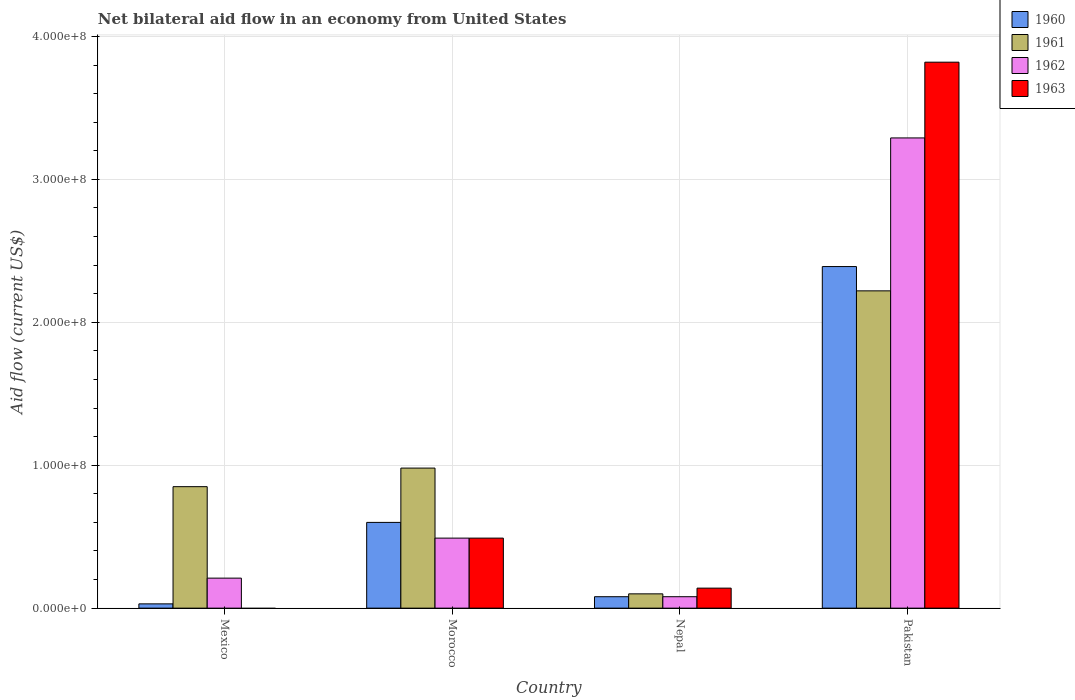How many different coloured bars are there?
Provide a succinct answer. 4. How many groups of bars are there?
Make the answer very short. 4. Are the number of bars on each tick of the X-axis equal?
Your answer should be compact. No. How many bars are there on the 3rd tick from the right?
Make the answer very short. 4. What is the label of the 3rd group of bars from the left?
Ensure brevity in your answer.  Nepal. What is the net bilateral aid flow in 1961 in Morocco?
Your answer should be very brief. 9.80e+07. Across all countries, what is the maximum net bilateral aid flow in 1960?
Keep it short and to the point. 2.39e+08. Across all countries, what is the minimum net bilateral aid flow in 1963?
Offer a terse response. 0. In which country was the net bilateral aid flow in 1961 maximum?
Offer a terse response. Pakistan. What is the total net bilateral aid flow in 1961 in the graph?
Ensure brevity in your answer.  4.15e+08. What is the difference between the net bilateral aid flow in 1962 in Nepal and that in Pakistan?
Make the answer very short. -3.21e+08. What is the difference between the net bilateral aid flow in 1962 in Mexico and the net bilateral aid flow in 1963 in Pakistan?
Your answer should be very brief. -3.61e+08. What is the average net bilateral aid flow in 1963 per country?
Your response must be concise. 1.11e+08. What is the difference between the net bilateral aid flow of/in 1963 and net bilateral aid flow of/in 1961 in Pakistan?
Keep it short and to the point. 1.60e+08. In how many countries, is the net bilateral aid flow in 1962 greater than 300000000 US$?
Offer a terse response. 1. What is the ratio of the net bilateral aid flow in 1963 in Morocco to that in Pakistan?
Offer a very short reply. 0.13. What is the difference between the highest and the second highest net bilateral aid flow in 1960?
Make the answer very short. 1.79e+08. What is the difference between the highest and the lowest net bilateral aid flow in 1961?
Your response must be concise. 2.12e+08. Is it the case that in every country, the sum of the net bilateral aid flow in 1961 and net bilateral aid flow in 1960 is greater than the sum of net bilateral aid flow in 1963 and net bilateral aid flow in 1962?
Keep it short and to the point. No. Is it the case that in every country, the sum of the net bilateral aid flow in 1961 and net bilateral aid flow in 1963 is greater than the net bilateral aid flow in 1960?
Ensure brevity in your answer.  Yes. How many bars are there?
Provide a short and direct response. 15. Are all the bars in the graph horizontal?
Your answer should be compact. No. How many countries are there in the graph?
Give a very brief answer. 4. Are the values on the major ticks of Y-axis written in scientific E-notation?
Your answer should be very brief. Yes. Does the graph contain any zero values?
Ensure brevity in your answer.  Yes. Where does the legend appear in the graph?
Offer a terse response. Top right. How many legend labels are there?
Your answer should be compact. 4. What is the title of the graph?
Your answer should be compact. Net bilateral aid flow in an economy from United States. What is the label or title of the X-axis?
Keep it short and to the point. Country. What is the label or title of the Y-axis?
Give a very brief answer. Aid flow (current US$). What is the Aid flow (current US$) of 1960 in Mexico?
Provide a short and direct response. 3.00e+06. What is the Aid flow (current US$) in 1961 in Mexico?
Make the answer very short. 8.50e+07. What is the Aid flow (current US$) of 1962 in Mexico?
Give a very brief answer. 2.10e+07. What is the Aid flow (current US$) in 1960 in Morocco?
Offer a terse response. 6.00e+07. What is the Aid flow (current US$) of 1961 in Morocco?
Make the answer very short. 9.80e+07. What is the Aid flow (current US$) in 1962 in Morocco?
Your answer should be compact. 4.90e+07. What is the Aid flow (current US$) in 1963 in Morocco?
Your answer should be compact. 4.90e+07. What is the Aid flow (current US$) in 1962 in Nepal?
Your response must be concise. 8.00e+06. What is the Aid flow (current US$) in 1963 in Nepal?
Ensure brevity in your answer.  1.40e+07. What is the Aid flow (current US$) in 1960 in Pakistan?
Offer a terse response. 2.39e+08. What is the Aid flow (current US$) in 1961 in Pakistan?
Offer a very short reply. 2.22e+08. What is the Aid flow (current US$) of 1962 in Pakistan?
Ensure brevity in your answer.  3.29e+08. What is the Aid flow (current US$) of 1963 in Pakistan?
Ensure brevity in your answer.  3.82e+08. Across all countries, what is the maximum Aid flow (current US$) in 1960?
Keep it short and to the point. 2.39e+08. Across all countries, what is the maximum Aid flow (current US$) in 1961?
Keep it short and to the point. 2.22e+08. Across all countries, what is the maximum Aid flow (current US$) of 1962?
Give a very brief answer. 3.29e+08. Across all countries, what is the maximum Aid flow (current US$) of 1963?
Give a very brief answer. 3.82e+08. Across all countries, what is the minimum Aid flow (current US$) of 1960?
Your answer should be compact. 3.00e+06. Across all countries, what is the minimum Aid flow (current US$) in 1963?
Your response must be concise. 0. What is the total Aid flow (current US$) of 1960 in the graph?
Keep it short and to the point. 3.10e+08. What is the total Aid flow (current US$) in 1961 in the graph?
Your answer should be compact. 4.15e+08. What is the total Aid flow (current US$) in 1962 in the graph?
Offer a terse response. 4.07e+08. What is the total Aid flow (current US$) of 1963 in the graph?
Your answer should be compact. 4.45e+08. What is the difference between the Aid flow (current US$) of 1960 in Mexico and that in Morocco?
Keep it short and to the point. -5.70e+07. What is the difference between the Aid flow (current US$) in 1961 in Mexico and that in Morocco?
Make the answer very short. -1.30e+07. What is the difference between the Aid flow (current US$) of 1962 in Mexico and that in Morocco?
Offer a very short reply. -2.80e+07. What is the difference between the Aid flow (current US$) in 1960 in Mexico and that in Nepal?
Offer a very short reply. -5.00e+06. What is the difference between the Aid flow (current US$) in 1961 in Mexico and that in Nepal?
Provide a short and direct response. 7.50e+07. What is the difference between the Aid flow (current US$) of 1962 in Mexico and that in Nepal?
Ensure brevity in your answer.  1.30e+07. What is the difference between the Aid flow (current US$) of 1960 in Mexico and that in Pakistan?
Your response must be concise. -2.36e+08. What is the difference between the Aid flow (current US$) in 1961 in Mexico and that in Pakistan?
Provide a short and direct response. -1.37e+08. What is the difference between the Aid flow (current US$) in 1962 in Mexico and that in Pakistan?
Keep it short and to the point. -3.08e+08. What is the difference between the Aid flow (current US$) of 1960 in Morocco and that in Nepal?
Offer a very short reply. 5.20e+07. What is the difference between the Aid flow (current US$) in 1961 in Morocco and that in Nepal?
Ensure brevity in your answer.  8.80e+07. What is the difference between the Aid flow (current US$) of 1962 in Morocco and that in Nepal?
Ensure brevity in your answer.  4.10e+07. What is the difference between the Aid flow (current US$) in 1963 in Morocco and that in Nepal?
Ensure brevity in your answer.  3.50e+07. What is the difference between the Aid flow (current US$) in 1960 in Morocco and that in Pakistan?
Your answer should be very brief. -1.79e+08. What is the difference between the Aid flow (current US$) of 1961 in Morocco and that in Pakistan?
Provide a succinct answer. -1.24e+08. What is the difference between the Aid flow (current US$) in 1962 in Morocco and that in Pakistan?
Make the answer very short. -2.80e+08. What is the difference between the Aid flow (current US$) of 1963 in Morocco and that in Pakistan?
Your response must be concise. -3.33e+08. What is the difference between the Aid flow (current US$) of 1960 in Nepal and that in Pakistan?
Give a very brief answer. -2.31e+08. What is the difference between the Aid flow (current US$) in 1961 in Nepal and that in Pakistan?
Keep it short and to the point. -2.12e+08. What is the difference between the Aid flow (current US$) in 1962 in Nepal and that in Pakistan?
Give a very brief answer. -3.21e+08. What is the difference between the Aid flow (current US$) of 1963 in Nepal and that in Pakistan?
Provide a succinct answer. -3.68e+08. What is the difference between the Aid flow (current US$) in 1960 in Mexico and the Aid flow (current US$) in 1961 in Morocco?
Offer a very short reply. -9.50e+07. What is the difference between the Aid flow (current US$) of 1960 in Mexico and the Aid flow (current US$) of 1962 in Morocco?
Offer a very short reply. -4.60e+07. What is the difference between the Aid flow (current US$) of 1960 in Mexico and the Aid flow (current US$) of 1963 in Morocco?
Your response must be concise. -4.60e+07. What is the difference between the Aid flow (current US$) of 1961 in Mexico and the Aid flow (current US$) of 1962 in Morocco?
Give a very brief answer. 3.60e+07. What is the difference between the Aid flow (current US$) in 1961 in Mexico and the Aid flow (current US$) in 1963 in Morocco?
Keep it short and to the point. 3.60e+07. What is the difference between the Aid flow (current US$) of 1962 in Mexico and the Aid flow (current US$) of 1963 in Morocco?
Offer a terse response. -2.80e+07. What is the difference between the Aid flow (current US$) of 1960 in Mexico and the Aid flow (current US$) of 1961 in Nepal?
Your answer should be very brief. -7.00e+06. What is the difference between the Aid flow (current US$) in 1960 in Mexico and the Aid flow (current US$) in 1962 in Nepal?
Keep it short and to the point. -5.00e+06. What is the difference between the Aid flow (current US$) in 1960 in Mexico and the Aid flow (current US$) in 1963 in Nepal?
Your answer should be very brief. -1.10e+07. What is the difference between the Aid flow (current US$) in 1961 in Mexico and the Aid flow (current US$) in 1962 in Nepal?
Keep it short and to the point. 7.70e+07. What is the difference between the Aid flow (current US$) in 1961 in Mexico and the Aid flow (current US$) in 1963 in Nepal?
Offer a terse response. 7.10e+07. What is the difference between the Aid flow (current US$) in 1960 in Mexico and the Aid flow (current US$) in 1961 in Pakistan?
Provide a succinct answer. -2.19e+08. What is the difference between the Aid flow (current US$) in 1960 in Mexico and the Aid flow (current US$) in 1962 in Pakistan?
Your response must be concise. -3.26e+08. What is the difference between the Aid flow (current US$) in 1960 in Mexico and the Aid flow (current US$) in 1963 in Pakistan?
Your answer should be very brief. -3.79e+08. What is the difference between the Aid flow (current US$) in 1961 in Mexico and the Aid flow (current US$) in 1962 in Pakistan?
Provide a short and direct response. -2.44e+08. What is the difference between the Aid flow (current US$) of 1961 in Mexico and the Aid flow (current US$) of 1963 in Pakistan?
Ensure brevity in your answer.  -2.97e+08. What is the difference between the Aid flow (current US$) of 1962 in Mexico and the Aid flow (current US$) of 1963 in Pakistan?
Provide a succinct answer. -3.61e+08. What is the difference between the Aid flow (current US$) of 1960 in Morocco and the Aid flow (current US$) of 1961 in Nepal?
Offer a terse response. 5.00e+07. What is the difference between the Aid flow (current US$) in 1960 in Morocco and the Aid flow (current US$) in 1962 in Nepal?
Your answer should be very brief. 5.20e+07. What is the difference between the Aid flow (current US$) in 1960 in Morocco and the Aid flow (current US$) in 1963 in Nepal?
Make the answer very short. 4.60e+07. What is the difference between the Aid flow (current US$) of 1961 in Morocco and the Aid flow (current US$) of 1962 in Nepal?
Your response must be concise. 9.00e+07. What is the difference between the Aid flow (current US$) of 1961 in Morocco and the Aid flow (current US$) of 1963 in Nepal?
Provide a short and direct response. 8.40e+07. What is the difference between the Aid flow (current US$) of 1962 in Morocco and the Aid flow (current US$) of 1963 in Nepal?
Your answer should be compact. 3.50e+07. What is the difference between the Aid flow (current US$) of 1960 in Morocco and the Aid flow (current US$) of 1961 in Pakistan?
Offer a terse response. -1.62e+08. What is the difference between the Aid flow (current US$) of 1960 in Morocco and the Aid flow (current US$) of 1962 in Pakistan?
Your response must be concise. -2.69e+08. What is the difference between the Aid flow (current US$) in 1960 in Morocco and the Aid flow (current US$) in 1963 in Pakistan?
Your answer should be compact. -3.22e+08. What is the difference between the Aid flow (current US$) of 1961 in Morocco and the Aid flow (current US$) of 1962 in Pakistan?
Offer a very short reply. -2.31e+08. What is the difference between the Aid flow (current US$) in 1961 in Morocco and the Aid flow (current US$) in 1963 in Pakistan?
Give a very brief answer. -2.84e+08. What is the difference between the Aid flow (current US$) of 1962 in Morocco and the Aid flow (current US$) of 1963 in Pakistan?
Your answer should be very brief. -3.33e+08. What is the difference between the Aid flow (current US$) of 1960 in Nepal and the Aid flow (current US$) of 1961 in Pakistan?
Keep it short and to the point. -2.14e+08. What is the difference between the Aid flow (current US$) of 1960 in Nepal and the Aid flow (current US$) of 1962 in Pakistan?
Ensure brevity in your answer.  -3.21e+08. What is the difference between the Aid flow (current US$) of 1960 in Nepal and the Aid flow (current US$) of 1963 in Pakistan?
Ensure brevity in your answer.  -3.74e+08. What is the difference between the Aid flow (current US$) in 1961 in Nepal and the Aid flow (current US$) in 1962 in Pakistan?
Ensure brevity in your answer.  -3.19e+08. What is the difference between the Aid flow (current US$) of 1961 in Nepal and the Aid flow (current US$) of 1963 in Pakistan?
Ensure brevity in your answer.  -3.72e+08. What is the difference between the Aid flow (current US$) of 1962 in Nepal and the Aid flow (current US$) of 1963 in Pakistan?
Your answer should be very brief. -3.74e+08. What is the average Aid flow (current US$) of 1960 per country?
Give a very brief answer. 7.75e+07. What is the average Aid flow (current US$) in 1961 per country?
Your answer should be compact. 1.04e+08. What is the average Aid flow (current US$) in 1962 per country?
Offer a very short reply. 1.02e+08. What is the average Aid flow (current US$) in 1963 per country?
Make the answer very short. 1.11e+08. What is the difference between the Aid flow (current US$) of 1960 and Aid flow (current US$) of 1961 in Mexico?
Offer a terse response. -8.20e+07. What is the difference between the Aid flow (current US$) in 1960 and Aid flow (current US$) in 1962 in Mexico?
Provide a succinct answer. -1.80e+07. What is the difference between the Aid flow (current US$) of 1961 and Aid flow (current US$) of 1962 in Mexico?
Your answer should be compact. 6.40e+07. What is the difference between the Aid flow (current US$) of 1960 and Aid flow (current US$) of 1961 in Morocco?
Ensure brevity in your answer.  -3.80e+07. What is the difference between the Aid flow (current US$) in 1960 and Aid flow (current US$) in 1962 in Morocco?
Your answer should be compact. 1.10e+07. What is the difference between the Aid flow (current US$) of 1960 and Aid flow (current US$) of 1963 in Morocco?
Give a very brief answer. 1.10e+07. What is the difference between the Aid flow (current US$) of 1961 and Aid flow (current US$) of 1962 in Morocco?
Make the answer very short. 4.90e+07. What is the difference between the Aid flow (current US$) in 1961 and Aid flow (current US$) in 1963 in Morocco?
Keep it short and to the point. 4.90e+07. What is the difference between the Aid flow (current US$) in 1960 and Aid flow (current US$) in 1962 in Nepal?
Your answer should be compact. 0. What is the difference between the Aid flow (current US$) of 1960 and Aid flow (current US$) of 1963 in Nepal?
Give a very brief answer. -6.00e+06. What is the difference between the Aid flow (current US$) of 1961 and Aid flow (current US$) of 1963 in Nepal?
Provide a short and direct response. -4.00e+06. What is the difference between the Aid flow (current US$) in 1962 and Aid flow (current US$) in 1963 in Nepal?
Make the answer very short. -6.00e+06. What is the difference between the Aid flow (current US$) in 1960 and Aid flow (current US$) in 1961 in Pakistan?
Your answer should be very brief. 1.70e+07. What is the difference between the Aid flow (current US$) of 1960 and Aid flow (current US$) of 1962 in Pakistan?
Offer a terse response. -9.00e+07. What is the difference between the Aid flow (current US$) of 1960 and Aid flow (current US$) of 1963 in Pakistan?
Provide a succinct answer. -1.43e+08. What is the difference between the Aid flow (current US$) of 1961 and Aid flow (current US$) of 1962 in Pakistan?
Keep it short and to the point. -1.07e+08. What is the difference between the Aid flow (current US$) of 1961 and Aid flow (current US$) of 1963 in Pakistan?
Your answer should be compact. -1.60e+08. What is the difference between the Aid flow (current US$) of 1962 and Aid flow (current US$) of 1963 in Pakistan?
Keep it short and to the point. -5.30e+07. What is the ratio of the Aid flow (current US$) in 1961 in Mexico to that in Morocco?
Your response must be concise. 0.87. What is the ratio of the Aid flow (current US$) in 1962 in Mexico to that in Morocco?
Ensure brevity in your answer.  0.43. What is the ratio of the Aid flow (current US$) of 1961 in Mexico to that in Nepal?
Provide a succinct answer. 8.5. What is the ratio of the Aid flow (current US$) of 1962 in Mexico to that in Nepal?
Provide a short and direct response. 2.62. What is the ratio of the Aid flow (current US$) of 1960 in Mexico to that in Pakistan?
Your answer should be compact. 0.01. What is the ratio of the Aid flow (current US$) in 1961 in Mexico to that in Pakistan?
Provide a succinct answer. 0.38. What is the ratio of the Aid flow (current US$) of 1962 in Mexico to that in Pakistan?
Offer a very short reply. 0.06. What is the ratio of the Aid flow (current US$) in 1961 in Morocco to that in Nepal?
Give a very brief answer. 9.8. What is the ratio of the Aid flow (current US$) of 1962 in Morocco to that in Nepal?
Your answer should be compact. 6.12. What is the ratio of the Aid flow (current US$) in 1963 in Morocco to that in Nepal?
Keep it short and to the point. 3.5. What is the ratio of the Aid flow (current US$) in 1960 in Morocco to that in Pakistan?
Ensure brevity in your answer.  0.25. What is the ratio of the Aid flow (current US$) of 1961 in Morocco to that in Pakistan?
Provide a succinct answer. 0.44. What is the ratio of the Aid flow (current US$) of 1962 in Morocco to that in Pakistan?
Make the answer very short. 0.15. What is the ratio of the Aid flow (current US$) of 1963 in Morocco to that in Pakistan?
Offer a terse response. 0.13. What is the ratio of the Aid flow (current US$) of 1960 in Nepal to that in Pakistan?
Offer a terse response. 0.03. What is the ratio of the Aid flow (current US$) in 1961 in Nepal to that in Pakistan?
Keep it short and to the point. 0.04. What is the ratio of the Aid flow (current US$) in 1962 in Nepal to that in Pakistan?
Ensure brevity in your answer.  0.02. What is the ratio of the Aid flow (current US$) of 1963 in Nepal to that in Pakistan?
Provide a short and direct response. 0.04. What is the difference between the highest and the second highest Aid flow (current US$) of 1960?
Ensure brevity in your answer.  1.79e+08. What is the difference between the highest and the second highest Aid flow (current US$) of 1961?
Keep it short and to the point. 1.24e+08. What is the difference between the highest and the second highest Aid flow (current US$) of 1962?
Your response must be concise. 2.80e+08. What is the difference between the highest and the second highest Aid flow (current US$) of 1963?
Your answer should be compact. 3.33e+08. What is the difference between the highest and the lowest Aid flow (current US$) of 1960?
Provide a short and direct response. 2.36e+08. What is the difference between the highest and the lowest Aid flow (current US$) of 1961?
Your answer should be very brief. 2.12e+08. What is the difference between the highest and the lowest Aid flow (current US$) in 1962?
Your answer should be compact. 3.21e+08. What is the difference between the highest and the lowest Aid flow (current US$) of 1963?
Provide a short and direct response. 3.82e+08. 